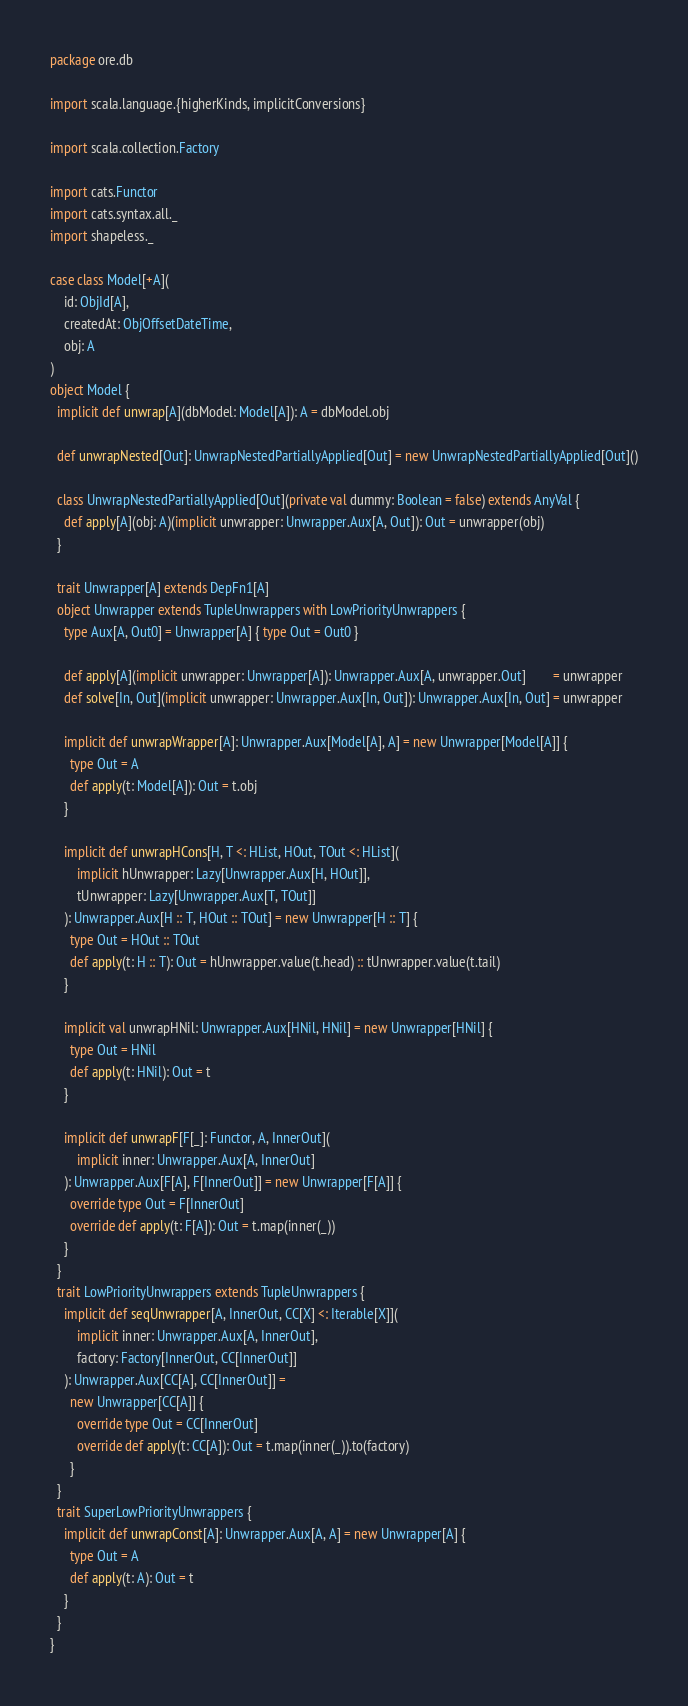Convert code to text. <code><loc_0><loc_0><loc_500><loc_500><_Scala_>package ore.db

import scala.language.{higherKinds, implicitConversions}

import scala.collection.Factory

import cats.Functor
import cats.syntax.all._
import shapeless._

case class Model[+A](
    id: ObjId[A],
    createdAt: ObjOffsetDateTime,
    obj: A
)
object Model {
  implicit def unwrap[A](dbModel: Model[A]): A = dbModel.obj

  def unwrapNested[Out]: UnwrapNestedPartiallyApplied[Out] = new UnwrapNestedPartiallyApplied[Out]()

  class UnwrapNestedPartiallyApplied[Out](private val dummy: Boolean = false) extends AnyVal {
    def apply[A](obj: A)(implicit unwrapper: Unwrapper.Aux[A, Out]): Out = unwrapper(obj)
  }

  trait Unwrapper[A] extends DepFn1[A]
  object Unwrapper extends TupleUnwrappers with LowPriorityUnwrappers {
    type Aux[A, Out0] = Unwrapper[A] { type Out = Out0 }

    def apply[A](implicit unwrapper: Unwrapper[A]): Unwrapper.Aux[A, unwrapper.Out]        = unwrapper
    def solve[In, Out](implicit unwrapper: Unwrapper.Aux[In, Out]): Unwrapper.Aux[In, Out] = unwrapper

    implicit def unwrapWrapper[A]: Unwrapper.Aux[Model[A], A] = new Unwrapper[Model[A]] {
      type Out = A
      def apply(t: Model[A]): Out = t.obj
    }

    implicit def unwrapHCons[H, T <: HList, HOut, TOut <: HList](
        implicit hUnwrapper: Lazy[Unwrapper.Aux[H, HOut]],
        tUnwrapper: Lazy[Unwrapper.Aux[T, TOut]]
    ): Unwrapper.Aux[H :: T, HOut :: TOut] = new Unwrapper[H :: T] {
      type Out = HOut :: TOut
      def apply(t: H :: T): Out = hUnwrapper.value(t.head) :: tUnwrapper.value(t.tail)
    }

    implicit val unwrapHNil: Unwrapper.Aux[HNil, HNil] = new Unwrapper[HNil] {
      type Out = HNil
      def apply(t: HNil): Out = t
    }

    implicit def unwrapF[F[_]: Functor, A, InnerOut](
        implicit inner: Unwrapper.Aux[A, InnerOut]
    ): Unwrapper.Aux[F[A], F[InnerOut]] = new Unwrapper[F[A]] {
      override type Out = F[InnerOut]
      override def apply(t: F[A]): Out = t.map(inner(_))
    }
  }
  trait LowPriorityUnwrappers extends TupleUnwrappers {
    implicit def seqUnwrapper[A, InnerOut, CC[X] <: Iterable[X]](
        implicit inner: Unwrapper.Aux[A, InnerOut],
        factory: Factory[InnerOut, CC[InnerOut]]
    ): Unwrapper.Aux[CC[A], CC[InnerOut]] =
      new Unwrapper[CC[A]] {
        override type Out = CC[InnerOut]
        override def apply(t: CC[A]): Out = t.map(inner(_)).to(factory)
      }
  }
  trait SuperLowPriorityUnwrappers {
    implicit def unwrapConst[A]: Unwrapper.Aux[A, A] = new Unwrapper[A] {
      type Out = A
      def apply(t: A): Out = t
    }
  }
}
</code> 